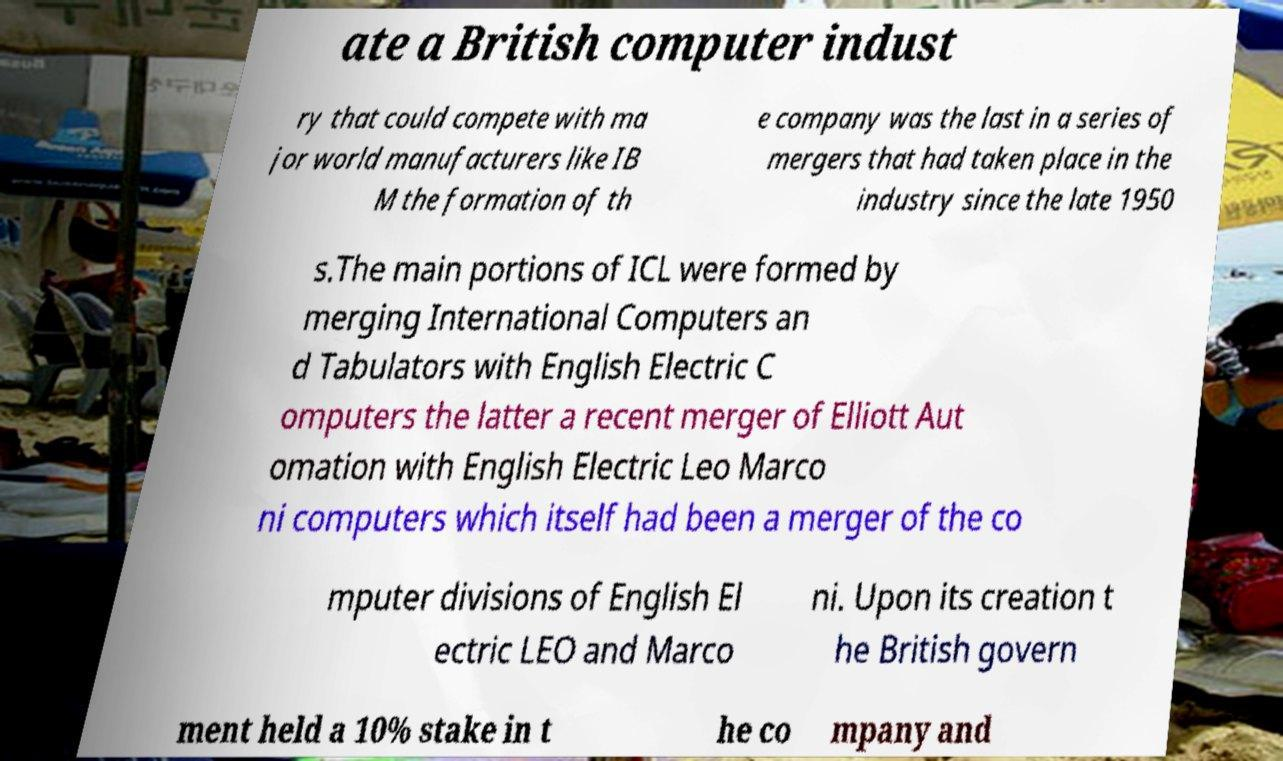Can you read and provide the text displayed in the image?This photo seems to have some interesting text. Can you extract and type it out for me? ate a British computer indust ry that could compete with ma jor world manufacturers like IB M the formation of th e company was the last in a series of mergers that had taken place in the industry since the late 1950 s.The main portions of ICL were formed by merging International Computers an d Tabulators with English Electric C omputers the latter a recent merger of Elliott Aut omation with English Electric Leo Marco ni computers which itself had been a merger of the co mputer divisions of English El ectric LEO and Marco ni. Upon its creation t he British govern ment held a 10% stake in t he co mpany and 